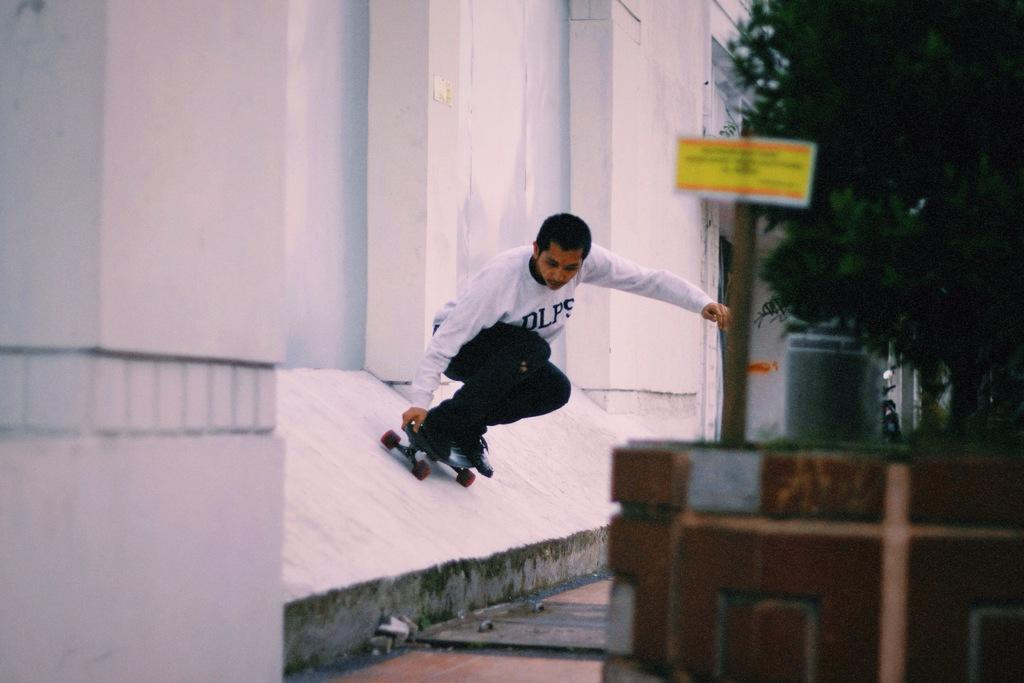Who is present in the image? There is a man in the image. What is the man doing in the image? The man is skating on a wall. What can be seen beside the man? There is a tree beside the man. What other object is present in the image? There is a pole with a board in the image. How many cows are visible in the image? There are no cows present in the image. What type of smile does the man have in the image? The image does not show the man's facial expression, so it cannot be determined if he is smiling or not. 